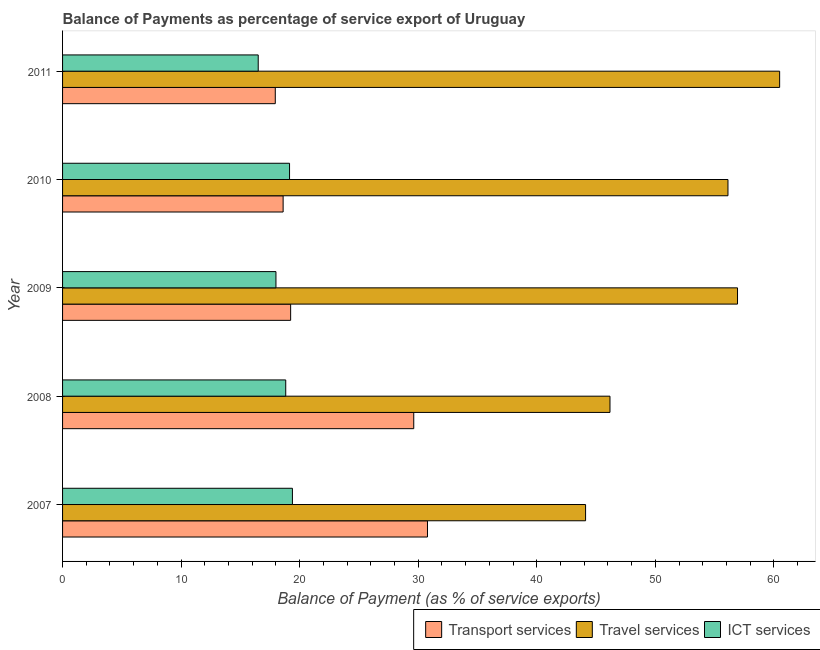How many different coloured bars are there?
Provide a short and direct response. 3. How many groups of bars are there?
Your response must be concise. 5. Are the number of bars on each tick of the Y-axis equal?
Provide a short and direct response. Yes. In how many cases, is the number of bars for a given year not equal to the number of legend labels?
Your answer should be very brief. 0. What is the balance of payment of travel services in 2009?
Give a very brief answer. 56.94. Across all years, what is the maximum balance of payment of transport services?
Keep it short and to the point. 30.78. Across all years, what is the minimum balance of payment of ict services?
Your response must be concise. 16.5. In which year was the balance of payment of ict services maximum?
Offer a very short reply. 2007. In which year was the balance of payment of transport services minimum?
Provide a short and direct response. 2011. What is the total balance of payment of ict services in the graph?
Keep it short and to the point. 91.87. What is the difference between the balance of payment of ict services in 2008 and that in 2011?
Offer a terse response. 2.32. What is the difference between the balance of payment of travel services in 2010 and the balance of payment of ict services in 2008?
Your response must be concise. 37.3. What is the average balance of payment of transport services per year?
Give a very brief answer. 23.24. In the year 2007, what is the difference between the balance of payment of ict services and balance of payment of travel services?
Ensure brevity in your answer.  -24.73. What is the ratio of the balance of payment of ict services in 2010 to that in 2011?
Ensure brevity in your answer.  1.16. What is the difference between the highest and the second highest balance of payment of travel services?
Your answer should be very brief. 3.55. What is the difference between the highest and the lowest balance of payment of travel services?
Make the answer very short. 16.37. In how many years, is the balance of payment of travel services greater than the average balance of payment of travel services taken over all years?
Give a very brief answer. 3. Is the sum of the balance of payment of travel services in 2008 and 2011 greater than the maximum balance of payment of transport services across all years?
Give a very brief answer. Yes. What does the 3rd bar from the top in 2007 represents?
Offer a very short reply. Transport services. What does the 3rd bar from the bottom in 2011 represents?
Offer a very short reply. ICT services. How many bars are there?
Make the answer very short. 15. Are all the bars in the graph horizontal?
Provide a short and direct response. Yes. Where does the legend appear in the graph?
Your response must be concise. Bottom right. How many legend labels are there?
Provide a short and direct response. 3. What is the title of the graph?
Provide a short and direct response. Balance of Payments as percentage of service export of Uruguay. Does "Nuclear sources" appear as one of the legend labels in the graph?
Make the answer very short. No. What is the label or title of the X-axis?
Keep it short and to the point. Balance of Payment (as % of service exports). What is the Balance of Payment (as % of service exports) in Transport services in 2007?
Your answer should be very brief. 30.78. What is the Balance of Payment (as % of service exports) in Travel services in 2007?
Your answer should be compact. 44.12. What is the Balance of Payment (as % of service exports) of ICT services in 2007?
Give a very brief answer. 19.39. What is the Balance of Payment (as % of service exports) of Transport services in 2008?
Offer a terse response. 29.62. What is the Balance of Payment (as % of service exports) in Travel services in 2008?
Your answer should be compact. 46.18. What is the Balance of Payment (as % of service exports) of ICT services in 2008?
Your response must be concise. 18.83. What is the Balance of Payment (as % of service exports) in Transport services in 2009?
Give a very brief answer. 19.24. What is the Balance of Payment (as % of service exports) of Travel services in 2009?
Your answer should be compact. 56.94. What is the Balance of Payment (as % of service exports) in ICT services in 2009?
Provide a succinct answer. 18. What is the Balance of Payment (as % of service exports) in Transport services in 2010?
Ensure brevity in your answer.  18.61. What is the Balance of Payment (as % of service exports) in Travel services in 2010?
Provide a succinct answer. 56.13. What is the Balance of Payment (as % of service exports) in ICT services in 2010?
Keep it short and to the point. 19.15. What is the Balance of Payment (as % of service exports) in Transport services in 2011?
Offer a terse response. 17.94. What is the Balance of Payment (as % of service exports) of Travel services in 2011?
Offer a terse response. 60.49. What is the Balance of Payment (as % of service exports) of ICT services in 2011?
Your response must be concise. 16.5. Across all years, what is the maximum Balance of Payment (as % of service exports) of Transport services?
Provide a short and direct response. 30.78. Across all years, what is the maximum Balance of Payment (as % of service exports) of Travel services?
Offer a terse response. 60.49. Across all years, what is the maximum Balance of Payment (as % of service exports) in ICT services?
Offer a very short reply. 19.39. Across all years, what is the minimum Balance of Payment (as % of service exports) in Transport services?
Your answer should be very brief. 17.94. Across all years, what is the minimum Balance of Payment (as % of service exports) in Travel services?
Give a very brief answer. 44.12. Across all years, what is the minimum Balance of Payment (as % of service exports) of ICT services?
Make the answer very short. 16.5. What is the total Balance of Payment (as % of service exports) in Transport services in the graph?
Provide a short and direct response. 116.2. What is the total Balance of Payment (as % of service exports) in Travel services in the graph?
Your answer should be compact. 263.85. What is the total Balance of Payment (as % of service exports) of ICT services in the graph?
Keep it short and to the point. 91.87. What is the difference between the Balance of Payment (as % of service exports) of Transport services in 2007 and that in 2008?
Give a very brief answer. 1.16. What is the difference between the Balance of Payment (as % of service exports) of Travel services in 2007 and that in 2008?
Your answer should be compact. -2.06. What is the difference between the Balance of Payment (as % of service exports) of ICT services in 2007 and that in 2008?
Offer a very short reply. 0.56. What is the difference between the Balance of Payment (as % of service exports) of Transport services in 2007 and that in 2009?
Offer a very short reply. 11.54. What is the difference between the Balance of Payment (as % of service exports) of Travel services in 2007 and that in 2009?
Ensure brevity in your answer.  -12.82. What is the difference between the Balance of Payment (as % of service exports) of ICT services in 2007 and that in 2009?
Your answer should be very brief. 1.39. What is the difference between the Balance of Payment (as % of service exports) in Transport services in 2007 and that in 2010?
Your answer should be compact. 12.18. What is the difference between the Balance of Payment (as % of service exports) of Travel services in 2007 and that in 2010?
Provide a short and direct response. -12.01. What is the difference between the Balance of Payment (as % of service exports) in ICT services in 2007 and that in 2010?
Offer a very short reply. 0.24. What is the difference between the Balance of Payment (as % of service exports) of Transport services in 2007 and that in 2011?
Your answer should be very brief. 12.84. What is the difference between the Balance of Payment (as % of service exports) in Travel services in 2007 and that in 2011?
Offer a terse response. -16.37. What is the difference between the Balance of Payment (as % of service exports) in ICT services in 2007 and that in 2011?
Provide a succinct answer. 2.89. What is the difference between the Balance of Payment (as % of service exports) in Transport services in 2008 and that in 2009?
Offer a very short reply. 10.39. What is the difference between the Balance of Payment (as % of service exports) of Travel services in 2008 and that in 2009?
Provide a succinct answer. -10.76. What is the difference between the Balance of Payment (as % of service exports) of ICT services in 2008 and that in 2009?
Your response must be concise. 0.83. What is the difference between the Balance of Payment (as % of service exports) in Transport services in 2008 and that in 2010?
Keep it short and to the point. 11.02. What is the difference between the Balance of Payment (as % of service exports) of Travel services in 2008 and that in 2010?
Ensure brevity in your answer.  -9.95. What is the difference between the Balance of Payment (as % of service exports) of ICT services in 2008 and that in 2010?
Keep it short and to the point. -0.32. What is the difference between the Balance of Payment (as % of service exports) of Transport services in 2008 and that in 2011?
Ensure brevity in your answer.  11.68. What is the difference between the Balance of Payment (as % of service exports) in Travel services in 2008 and that in 2011?
Ensure brevity in your answer.  -14.31. What is the difference between the Balance of Payment (as % of service exports) in ICT services in 2008 and that in 2011?
Provide a succinct answer. 2.32. What is the difference between the Balance of Payment (as % of service exports) of Transport services in 2009 and that in 2010?
Your response must be concise. 0.63. What is the difference between the Balance of Payment (as % of service exports) of Travel services in 2009 and that in 2010?
Offer a terse response. 0.8. What is the difference between the Balance of Payment (as % of service exports) in ICT services in 2009 and that in 2010?
Your answer should be compact. -1.15. What is the difference between the Balance of Payment (as % of service exports) of Transport services in 2009 and that in 2011?
Make the answer very short. 1.3. What is the difference between the Balance of Payment (as % of service exports) in Travel services in 2009 and that in 2011?
Your answer should be compact. -3.55. What is the difference between the Balance of Payment (as % of service exports) of ICT services in 2009 and that in 2011?
Your answer should be compact. 1.5. What is the difference between the Balance of Payment (as % of service exports) of Transport services in 2010 and that in 2011?
Keep it short and to the point. 0.66. What is the difference between the Balance of Payment (as % of service exports) in Travel services in 2010 and that in 2011?
Your answer should be compact. -4.36. What is the difference between the Balance of Payment (as % of service exports) in ICT services in 2010 and that in 2011?
Provide a short and direct response. 2.64. What is the difference between the Balance of Payment (as % of service exports) in Transport services in 2007 and the Balance of Payment (as % of service exports) in Travel services in 2008?
Offer a terse response. -15.4. What is the difference between the Balance of Payment (as % of service exports) in Transport services in 2007 and the Balance of Payment (as % of service exports) in ICT services in 2008?
Your response must be concise. 11.96. What is the difference between the Balance of Payment (as % of service exports) in Travel services in 2007 and the Balance of Payment (as % of service exports) in ICT services in 2008?
Keep it short and to the point. 25.29. What is the difference between the Balance of Payment (as % of service exports) in Transport services in 2007 and the Balance of Payment (as % of service exports) in Travel services in 2009?
Provide a succinct answer. -26.15. What is the difference between the Balance of Payment (as % of service exports) of Transport services in 2007 and the Balance of Payment (as % of service exports) of ICT services in 2009?
Offer a terse response. 12.78. What is the difference between the Balance of Payment (as % of service exports) of Travel services in 2007 and the Balance of Payment (as % of service exports) of ICT services in 2009?
Offer a very short reply. 26.12. What is the difference between the Balance of Payment (as % of service exports) in Transport services in 2007 and the Balance of Payment (as % of service exports) in Travel services in 2010?
Make the answer very short. -25.35. What is the difference between the Balance of Payment (as % of service exports) in Transport services in 2007 and the Balance of Payment (as % of service exports) in ICT services in 2010?
Offer a terse response. 11.64. What is the difference between the Balance of Payment (as % of service exports) in Travel services in 2007 and the Balance of Payment (as % of service exports) in ICT services in 2010?
Keep it short and to the point. 24.97. What is the difference between the Balance of Payment (as % of service exports) of Transport services in 2007 and the Balance of Payment (as % of service exports) of Travel services in 2011?
Provide a short and direct response. -29.71. What is the difference between the Balance of Payment (as % of service exports) of Transport services in 2007 and the Balance of Payment (as % of service exports) of ICT services in 2011?
Your answer should be very brief. 14.28. What is the difference between the Balance of Payment (as % of service exports) of Travel services in 2007 and the Balance of Payment (as % of service exports) of ICT services in 2011?
Ensure brevity in your answer.  27.61. What is the difference between the Balance of Payment (as % of service exports) of Transport services in 2008 and the Balance of Payment (as % of service exports) of Travel services in 2009?
Make the answer very short. -27.31. What is the difference between the Balance of Payment (as % of service exports) in Transport services in 2008 and the Balance of Payment (as % of service exports) in ICT services in 2009?
Give a very brief answer. 11.62. What is the difference between the Balance of Payment (as % of service exports) in Travel services in 2008 and the Balance of Payment (as % of service exports) in ICT services in 2009?
Keep it short and to the point. 28.18. What is the difference between the Balance of Payment (as % of service exports) in Transport services in 2008 and the Balance of Payment (as % of service exports) in Travel services in 2010?
Your response must be concise. -26.51. What is the difference between the Balance of Payment (as % of service exports) of Transport services in 2008 and the Balance of Payment (as % of service exports) of ICT services in 2010?
Make the answer very short. 10.48. What is the difference between the Balance of Payment (as % of service exports) of Travel services in 2008 and the Balance of Payment (as % of service exports) of ICT services in 2010?
Offer a terse response. 27.03. What is the difference between the Balance of Payment (as % of service exports) of Transport services in 2008 and the Balance of Payment (as % of service exports) of Travel services in 2011?
Provide a succinct answer. -30.86. What is the difference between the Balance of Payment (as % of service exports) in Transport services in 2008 and the Balance of Payment (as % of service exports) in ICT services in 2011?
Give a very brief answer. 13.12. What is the difference between the Balance of Payment (as % of service exports) of Travel services in 2008 and the Balance of Payment (as % of service exports) of ICT services in 2011?
Your answer should be compact. 29.67. What is the difference between the Balance of Payment (as % of service exports) in Transport services in 2009 and the Balance of Payment (as % of service exports) in Travel services in 2010?
Your response must be concise. -36.89. What is the difference between the Balance of Payment (as % of service exports) in Transport services in 2009 and the Balance of Payment (as % of service exports) in ICT services in 2010?
Your answer should be very brief. 0.09. What is the difference between the Balance of Payment (as % of service exports) of Travel services in 2009 and the Balance of Payment (as % of service exports) of ICT services in 2010?
Ensure brevity in your answer.  37.79. What is the difference between the Balance of Payment (as % of service exports) of Transport services in 2009 and the Balance of Payment (as % of service exports) of Travel services in 2011?
Ensure brevity in your answer.  -41.25. What is the difference between the Balance of Payment (as % of service exports) in Transport services in 2009 and the Balance of Payment (as % of service exports) in ICT services in 2011?
Your response must be concise. 2.73. What is the difference between the Balance of Payment (as % of service exports) of Travel services in 2009 and the Balance of Payment (as % of service exports) of ICT services in 2011?
Give a very brief answer. 40.43. What is the difference between the Balance of Payment (as % of service exports) in Transport services in 2010 and the Balance of Payment (as % of service exports) in Travel services in 2011?
Provide a succinct answer. -41.88. What is the difference between the Balance of Payment (as % of service exports) in Transport services in 2010 and the Balance of Payment (as % of service exports) in ICT services in 2011?
Your response must be concise. 2.1. What is the difference between the Balance of Payment (as % of service exports) in Travel services in 2010 and the Balance of Payment (as % of service exports) in ICT services in 2011?
Give a very brief answer. 39.63. What is the average Balance of Payment (as % of service exports) in Transport services per year?
Your answer should be very brief. 23.24. What is the average Balance of Payment (as % of service exports) in Travel services per year?
Your answer should be very brief. 52.77. What is the average Balance of Payment (as % of service exports) in ICT services per year?
Keep it short and to the point. 18.37. In the year 2007, what is the difference between the Balance of Payment (as % of service exports) in Transport services and Balance of Payment (as % of service exports) in Travel services?
Provide a short and direct response. -13.34. In the year 2007, what is the difference between the Balance of Payment (as % of service exports) in Transport services and Balance of Payment (as % of service exports) in ICT services?
Give a very brief answer. 11.39. In the year 2007, what is the difference between the Balance of Payment (as % of service exports) of Travel services and Balance of Payment (as % of service exports) of ICT services?
Offer a terse response. 24.73. In the year 2008, what is the difference between the Balance of Payment (as % of service exports) in Transport services and Balance of Payment (as % of service exports) in Travel services?
Your answer should be compact. -16.55. In the year 2008, what is the difference between the Balance of Payment (as % of service exports) of Transport services and Balance of Payment (as % of service exports) of ICT services?
Your answer should be compact. 10.8. In the year 2008, what is the difference between the Balance of Payment (as % of service exports) of Travel services and Balance of Payment (as % of service exports) of ICT services?
Keep it short and to the point. 27.35. In the year 2009, what is the difference between the Balance of Payment (as % of service exports) of Transport services and Balance of Payment (as % of service exports) of Travel services?
Offer a terse response. -37.7. In the year 2009, what is the difference between the Balance of Payment (as % of service exports) in Transport services and Balance of Payment (as % of service exports) in ICT services?
Your answer should be very brief. 1.24. In the year 2009, what is the difference between the Balance of Payment (as % of service exports) of Travel services and Balance of Payment (as % of service exports) of ICT services?
Make the answer very short. 38.94. In the year 2010, what is the difference between the Balance of Payment (as % of service exports) of Transport services and Balance of Payment (as % of service exports) of Travel services?
Offer a very short reply. -37.52. In the year 2010, what is the difference between the Balance of Payment (as % of service exports) of Transport services and Balance of Payment (as % of service exports) of ICT services?
Your answer should be compact. -0.54. In the year 2010, what is the difference between the Balance of Payment (as % of service exports) of Travel services and Balance of Payment (as % of service exports) of ICT services?
Your answer should be compact. 36.98. In the year 2011, what is the difference between the Balance of Payment (as % of service exports) of Transport services and Balance of Payment (as % of service exports) of Travel services?
Provide a short and direct response. -42.55. In the year 2011, what is the difference between the Balance of Payment (as % of service exports) in Transport services and Balance of Payment (as % of service exports) in ICT services?
Offer a terse response. 1.44. In the year 2011, what is the difference between the Balance of Payment (as % of service exports) of Travel services and Balance of Payment (as % of service exports) of ICT services?
Make the answer very short. 43.99. What is the ratio of the Balance of Payment (as % of service exports) of Transport services in 2007 to that in 2008?
Keep it short and to the point. 1.04. What is the ratio of the Balance of Payment (as % of service exports) in Travel services in 2007 to that in 2008?
Give a very brief answer. 0.96. What is the ratio of the Balance of Payment (as % of service exports) of ICT services in 2007 to that in 2008?
Give a very brief answer. 1.03. What is the ratio of the Balance of Payment (as % of service exports) of Travel services in 2007 to that in 2009?
Offer a terse response. 0.77. What is the ratio of the Balance of Payment (as % of service exports) of ICT services in 2007 to that in 2009?
Your answer should be compact. 1.08. What is the ratio of the Balance of Payment (as % of service exports) in Transport services in 2007 to that in 2010?
Offer a very short reply. 1.65. What is the ratio of the Balance of Payment (as % of service exports) in Travel services in 2007 to that in 2010?
Ensure brevity in your answer.  0.79. What is the ratio of the Balance of Payment (as % of service exports) of ICT services in 2007 to that in 2010?
Give a very brief answer. 1.01. What is the ratio of the Balance of Payment (as % of service exports) of Transport services in 2007 to that in 2011?
Give a very brief answer. 1.72. What is the ratio of the Balance of Payment (as % of service exports) in Travel services in 2007 to that in 2011?
Offer a terse response. 0.73. What is the ratio of the Balance of Payment (as % of service exports) in ICT services in 2007 to that in 2011?
Provide a short and direct response. 1.17. What is the ratio of the Balance of Payment (as % of service exports) in Transport services in 2008 to that in 2009?
Offer a very short reply. 1.54. What is the ratio of the Balance of Payment (as % of service exports) of Travel services in 2008 to that in 2009?
Give a very brief answer. 0.81. What is the ratio of the Balance of Payment (as % of service exports) in ICT services in 2008 to that in 2009?
Keep it short and to the point. 1.05. What is the ratio of the Balance of Payment (as % of service exports) of Transport services in 2008 to that in 2010?
Your answer should be very brief. 1.59. What is the ratio of the Balance of Payment (as % of service exports) of Travel services in 2008 to that in 2010?
Offer a terse response. 0.82. What is the ratio of the Balance of Payment (as % of service exports) of ICT services in 2008 to that in 2010?
Ensure brevity in your answer.  0.98. What is the ratio of the Balance of Payment (as % of service exports) of Transport services in 2008 to that in 2011?
Provide a succinct answer. 1.65. What is the ratio of the Balance of Payment (as % of service exports) in Travel services in 2008 to that in 2011?
Ensure brevity in your answer.  0.76. What is the ratio of the Balance of Payment (as % of service exports) of ICT services in 2008 to that in 2011?
Keep it short and to the point. 1.14. What is the ratio of the Balance of Payment (as % of service exports) in Transport services in 2009 to that in 2010?
Keep it short and to the point. 1.03. What is the ratio of the Balance of Payment (as % of service exports) in Travel services in 2009 to that in 2010?
Provide a succinct answer. 1.01. What is the ratio of the Balance of Payment (as % of service exports) of ICT services in 2009 to that in 2010?
Give a very brief answer. 0.94. What is the ratio of the Balance of Payment (as % of service exports) in Transport services in 2009 to that in 2011?
Provide a succinct answer. 1.07. What is the ratio of the Balance of Payment (as % of service exports) of Travel services in 2009 to that in 2011?
Provide a succinct answer. 0.94. What is the ratio of the Balance of Payment (as % of service exports) of ICT services in 2009 to that in 2011?
Give a very brief answer. 1.09. What is the ratio of the Balance of Payment (as % of service exports) in Transport services in 2010 to that in 2011?
Give a very brief answer. 1.04. What is the ratio of the Balance of Payment (as % of service exports) of Travel services in 2010 to that in 2011?
Provide a succinct answer. 0.93. What is the ratio of the Balance of Payment (as % of service exports) in ICT services in 2010 to that in 2011?
Your response must be concise. 1.16. What is the difference between the highest and the second highest Balance of Payment (as % of service exports) of Transport services?
Ensure brevity in your answer.  1.16. What is the difference between the highest and the second highest Balance of Payment (as % of service exports) in Travel services?
Provide a short and direct response. 3.55. What is the difference between the highest and the second highest Balance of Payment (as % of service exports) in ICT services?
Offer a very short reply. 0.24. What is the difference between the highest and the lowest Balance of Payment (as % of service exports) of Transport services?
Offer a terse response. 12.84. What is the difference between the highest and the lowest Balance of Payment (as % of service exports) in Travel services?
Give a very brief answer. 16.37. What is the difference between the highest and the lowest Balance of Payment (as % of service exports) in ICT services?
Offer a very short reply. 2.89. 